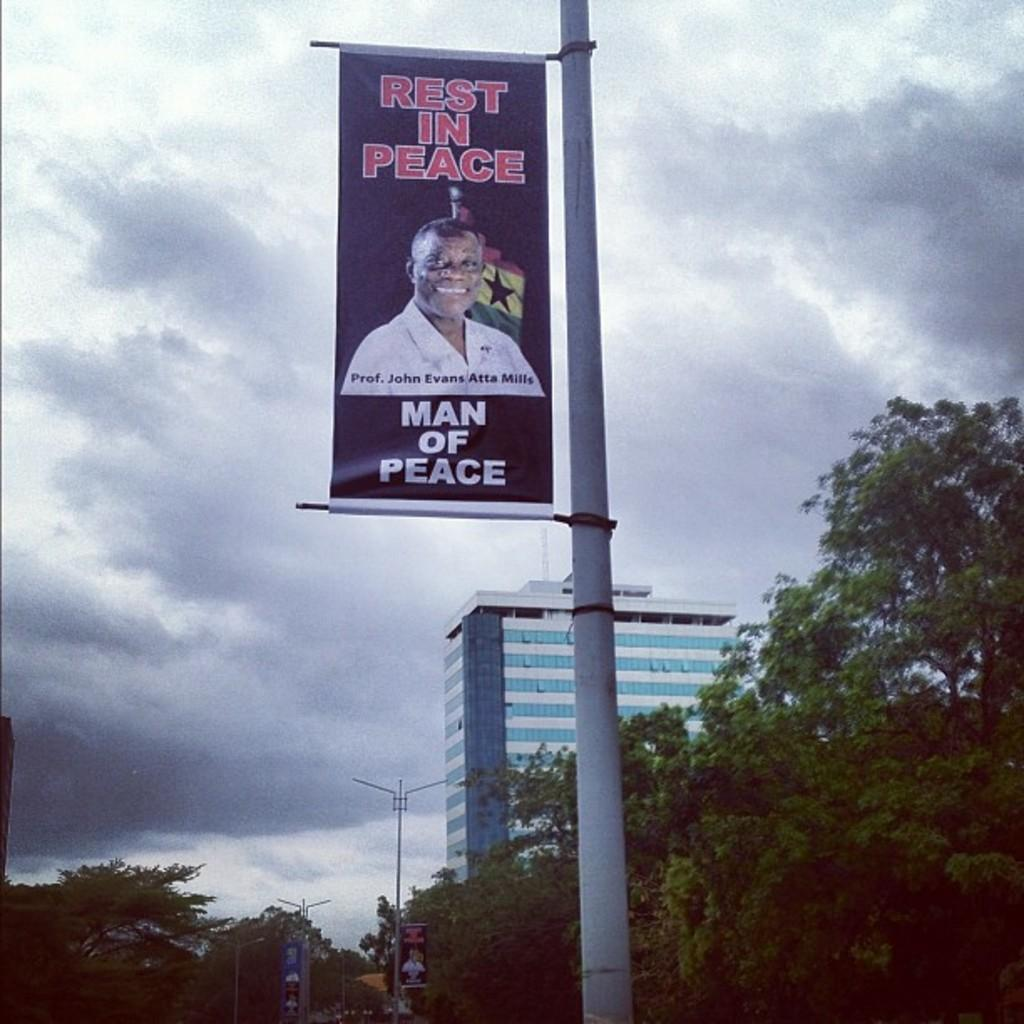Provide a one-sentence caption for the provided image. Professor John Evans Atta Mills, Man of Peace, has passed away. 